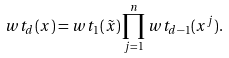Convert formula to latex. <formula><loc_0><loc_0><loc_500><loc_500>w t _ { d } ( x ) = w t _ { 1 } ( \tilde { x } ) \prod _ { j = 1 } ^ { n } w t _ { d - 1 } ( x ^ { j } ) .</formula> 